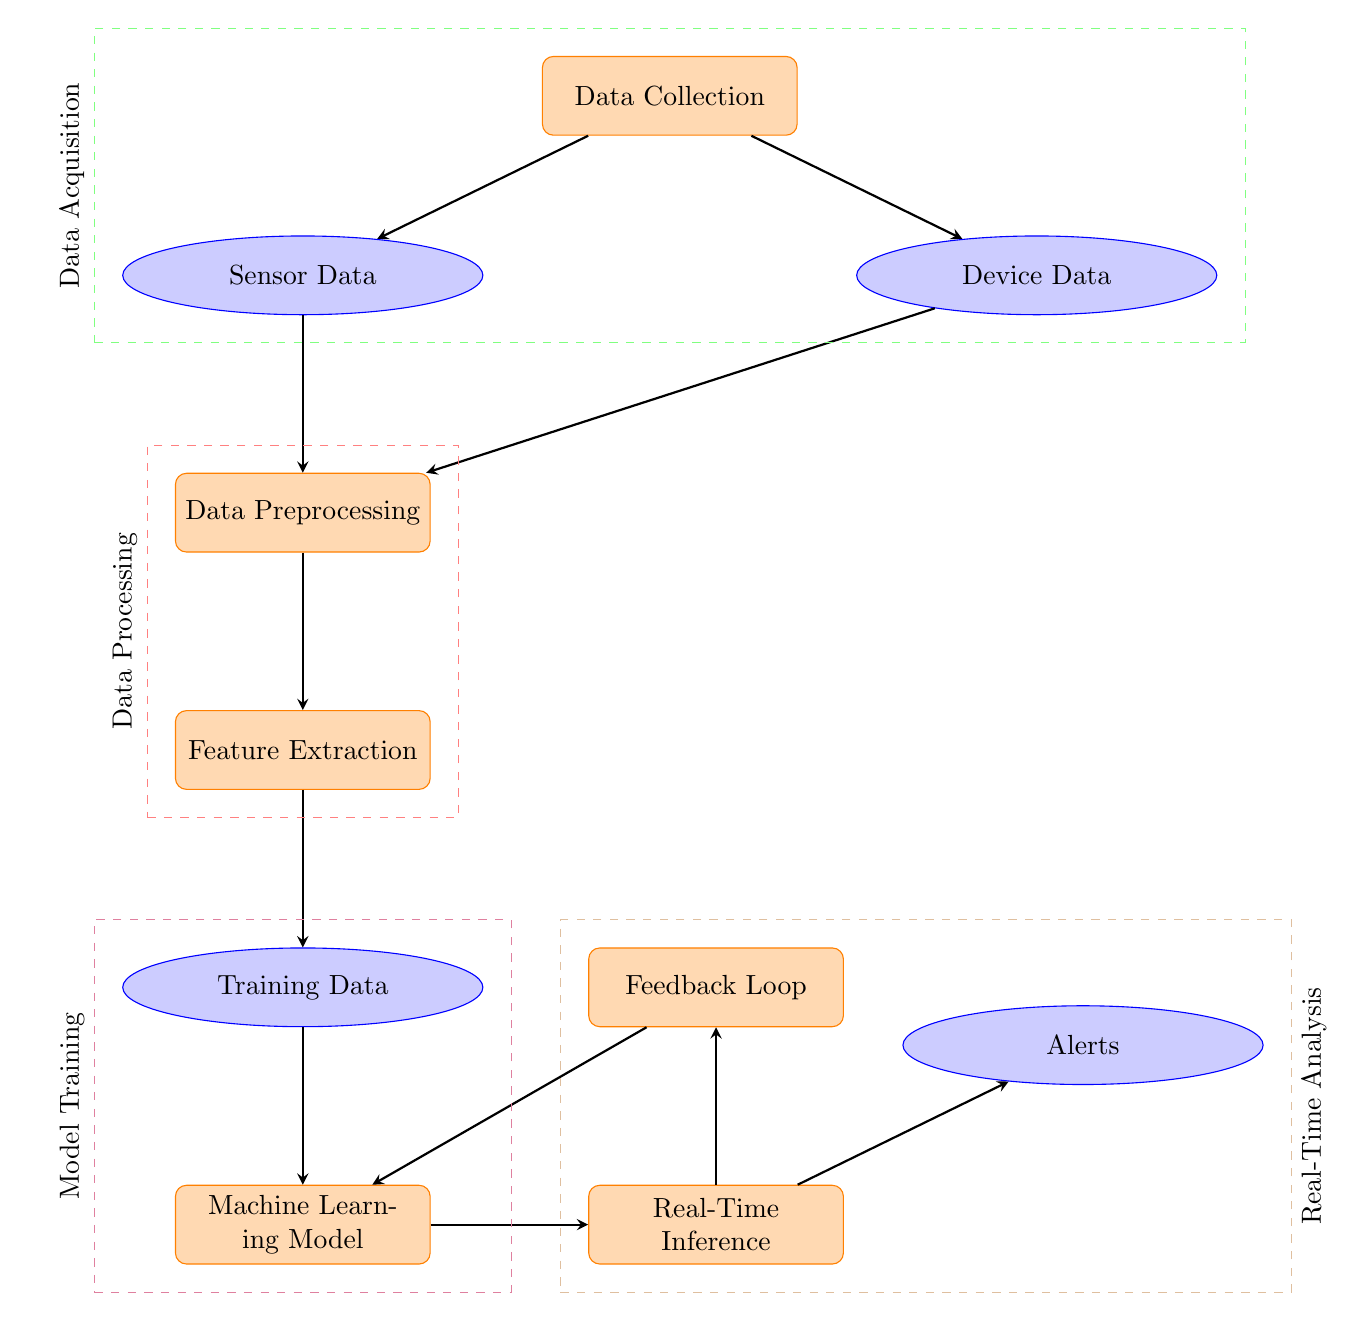What is the first process in the diagram? The first process node in the diagram is labeled "Data Collection," which represents the initial step in acquiring data.
Answer: Data Collection How many data nodes are present in the diagram? There are three data nodes in the diagram: "Sensor Data," "Device Data," and "Training Data."
Answer: Three What follows after Data Preprocessing in the diagram? After "Data Preprocessing," the next process in the flow is "Feature Extraction," indicating that features are derived from cleaned data.
Answer: Feature Extraction Which process is immediately connected to the Real-Time Inference? The process immediately connected to "Real-Time Inference" is the "Machine Learning Model," which means it receives input from the trained model for inference.
Answer: Machine Learning Model What is the purpose of the Feedback Loop in this diagram? The "Feedback Loop" is intended to collect feedback from the results of real-time analysis to improve the "Machine Learning Model," creating a cycle of learning and improvement.
Answer: Improve Model Which nodes fall under the category of Real-Time Analysis? The nodes that fall under "Real-Time Analysis" are "Real-Time Inference," "Alerts," and "Feedback Loop," indicating their roles in analyzing data in real time and responding to it.
Answer: Real-Time Inference, Alerts, Feedback Loop How many processes are outlined in the Model Training section? The "Model Training" section consists of two processes: "Training Data" and "Machine Learning Model," detailing the steps of developing the machine learning model.
Answer: Two What type of data is collected during the Data Collection phase? During the "Data Collection" phase, two types of data are collected: "Sensor Data" and "Device Data," which are crucial for health monitoring.
Answer: Sensor Data, Device Data 